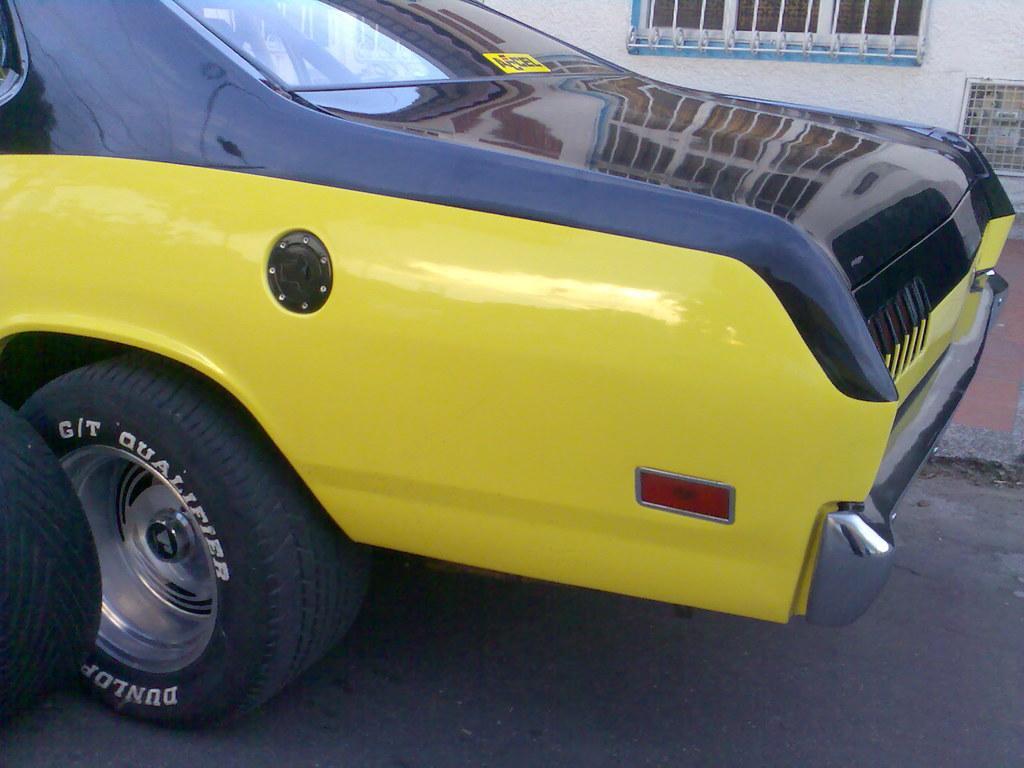Could you give a brief overview of what you see in this image? In the picture we can see back side part of the car with yellow and black in color and beside the car we can see a part of the path and a wall with a part of the window. 